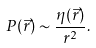<formula> <loc_0><loc_0><loc_500><loc_500>P ( \vec { r } ) \sim \frac { \eta ( \vec { r } ) } { r ^ { 2 } } .</formula> 